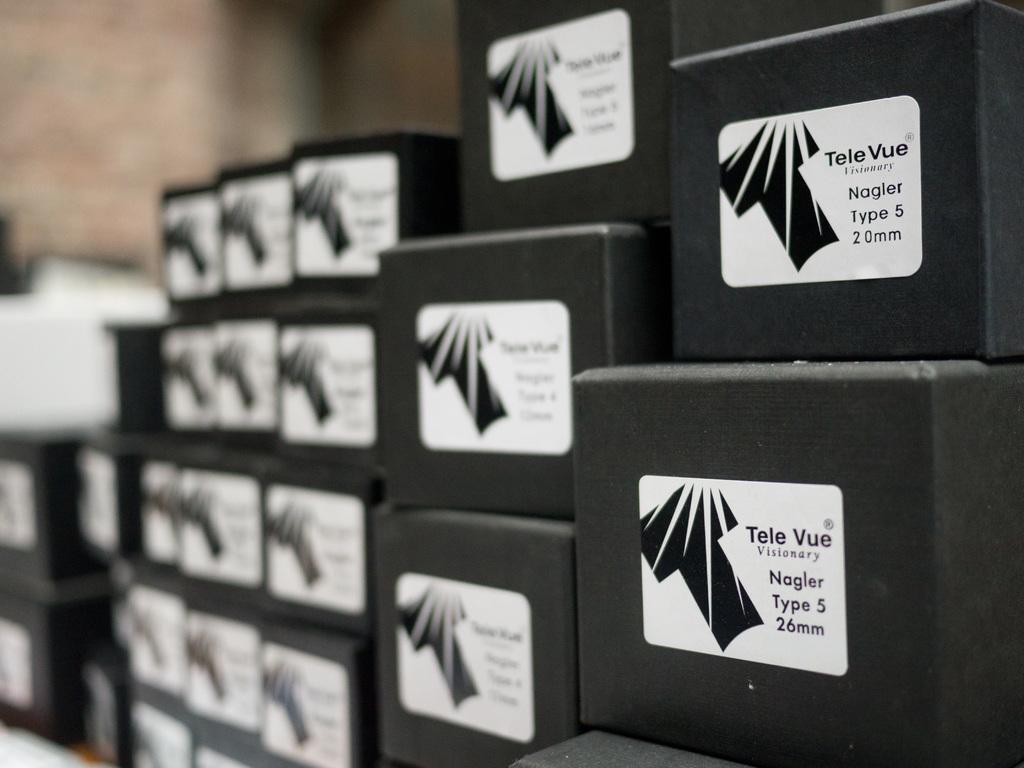What is the name of this components manufacture?
Your answer should be very brief. Tele vue. How many mm is the one on the right bottom box?
Keep it short and to the point. 26. 